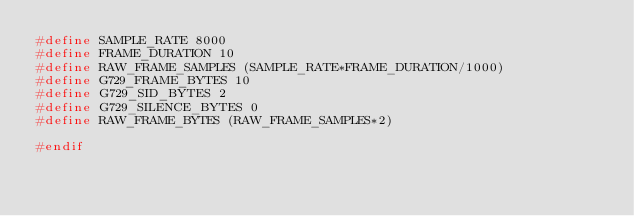<code> <loc_0><loc_0><loc_500><loc_500><_C_>#define SAMPLE_RATE 8000
#define FRAME_DURATION 10
#define RAW_FRAME_SAMPLES (SAMPLE_RATE*FRAME_DURATION/1000)
#define G729_FRAME_BYTES 10
#define G729_SID_BYTES 2
#define G729_SILENCE_BYTES 0
#define RAW_FRAME_BYTES (RAW_FRAME_SAMPLES*2)

#endif
</code> 